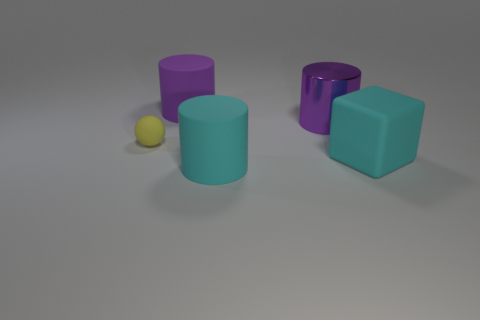Add 3 yellow matte balls. How many objects exist? 8 Subtract all spheres. How many objects are left? 4 Subtract all purple objects. Subtract all large blue matte objects. How many objects are left? 3 Add 3 metal objects. How many metal objects are left? 4 Add 1 big cyan cylinders. How many big cyan cylinders exist? 2 Subtract 1 yellow balls. How many objects are left? 4 